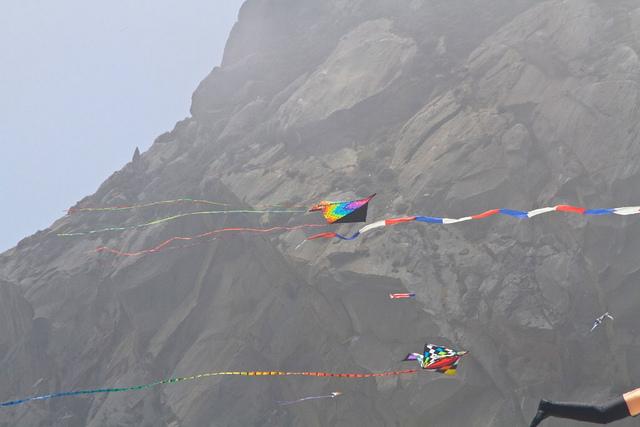Was this photo taken from the inside of an airplane?
Give a very brief answer. No. Are these large kites or small kites?
Be succinct. Large. How many kites are there?
Give a very brief answer. 5. 